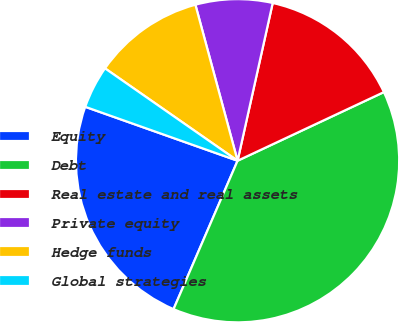Convert chart to OTSL. <chart><loc_0><loc_0><loc_500><loc_500><pie_chart><fcel>Equity<fcel>Debt<fcel>Real estate and real assets<fcel>Private equity<fcel>Hedge funds<fcel>Global strategies<nl><fcel>23.93%<fcel>38.46%<fcel>14.53%<fcel>7.69%<fcel>11.11%<fcel>4.27%<nl></chart> 